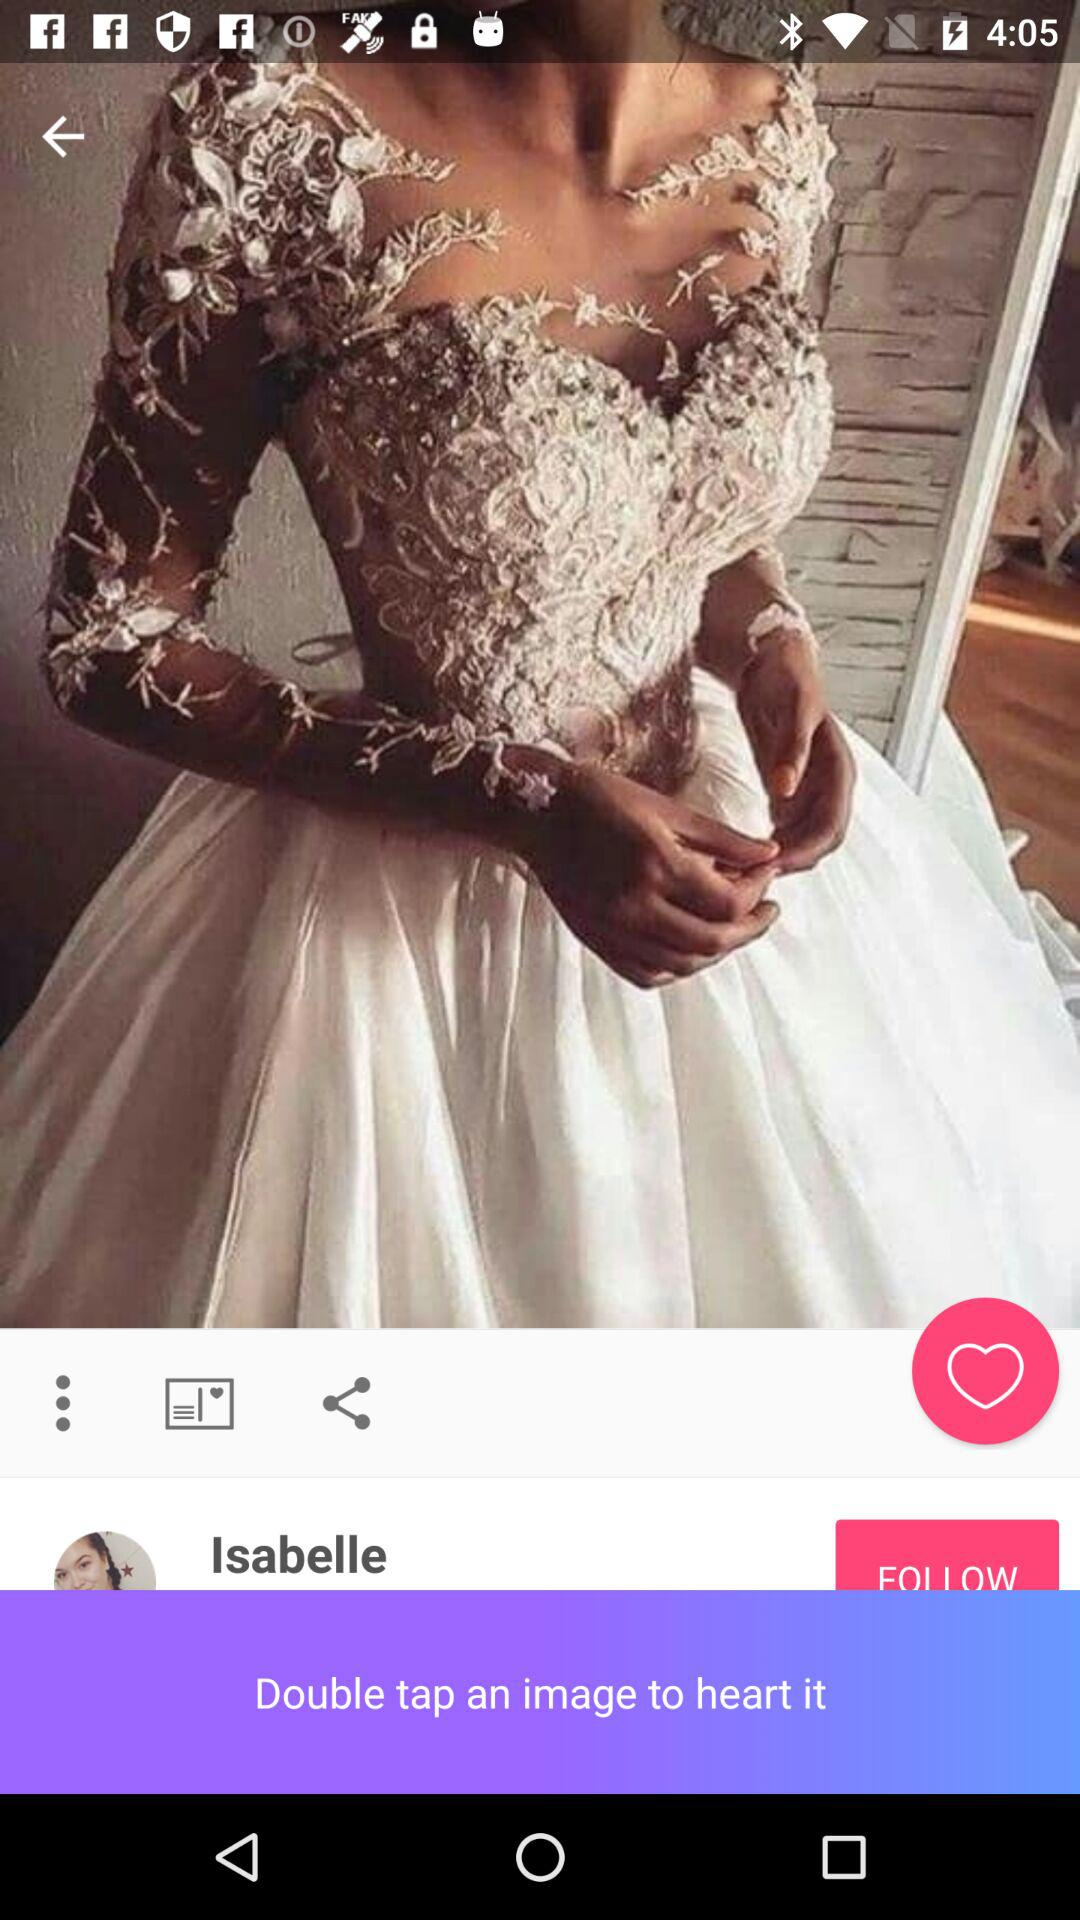What is the given profile name? The given profile name is Isabelle. 